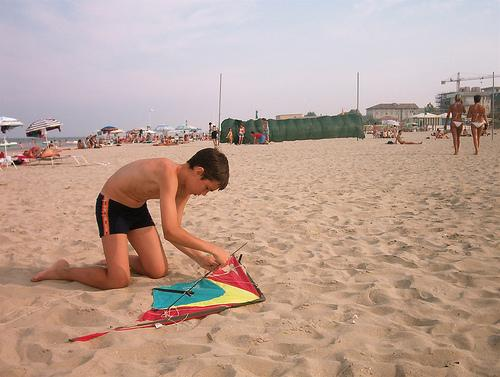Where does he hope his toy will go? sky 